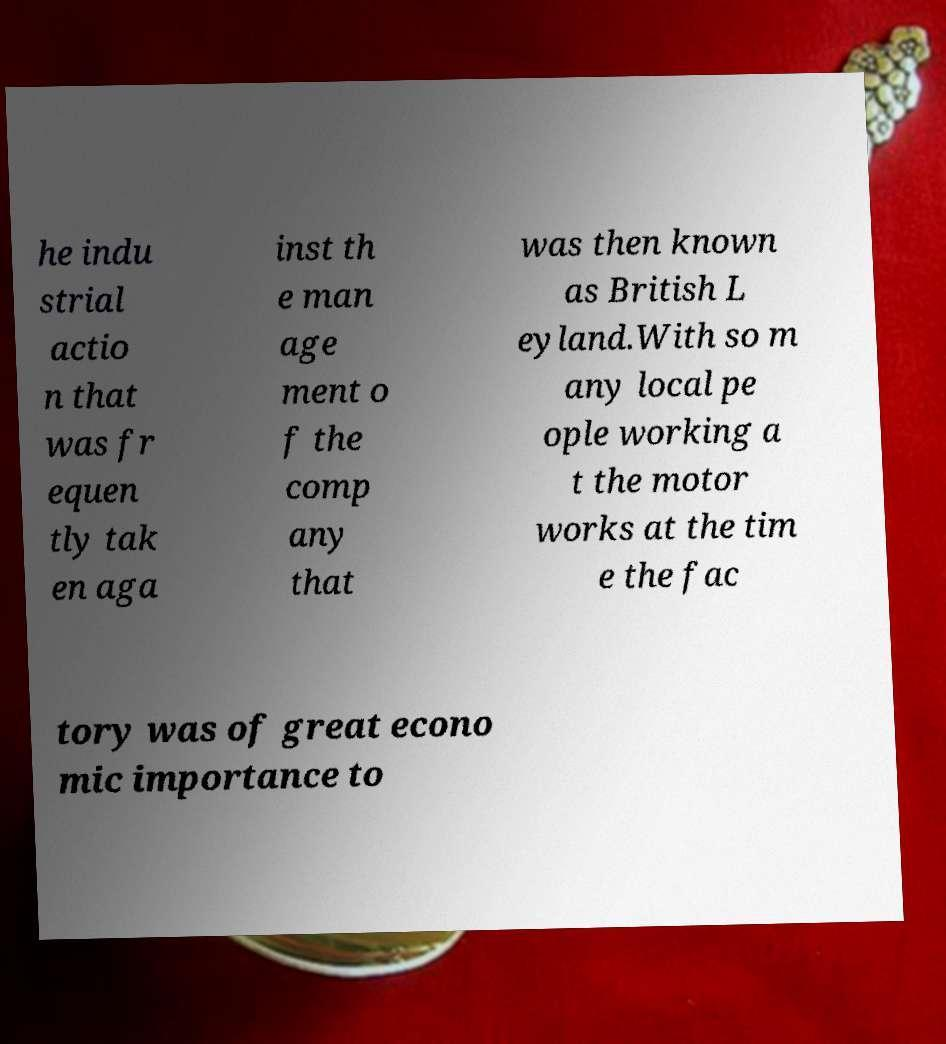Please read and relay the text visible in this image. What does it say? he indu strial actio n that was fr equen tly tak en aga inst th e man age ment o f the comp any that was then known as British L eyland.With so m any local pe ople working a t the motor works at the tim e the fac tory was of great econo mic importance to 